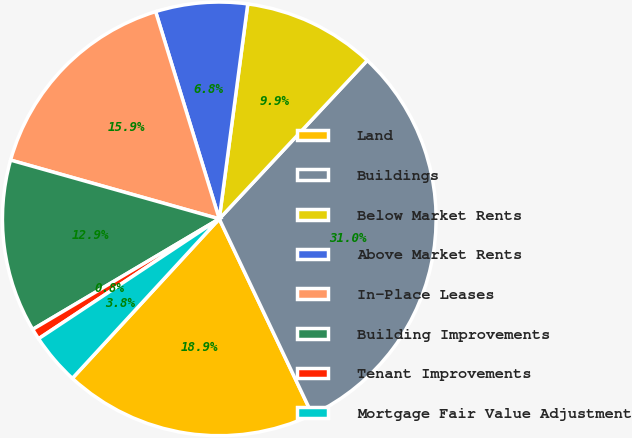Convert chart. <chart><loc_0><loc_0><loc_500><loc_500><pie_chart><fcel>Land<fcel>Buildings<fcel>Below Market Rents<fcel>Above Market Rents<fcel>In-Place Leases<fcel>Building Improvements<fcel>Tenant Improvements<fcel>Mortgage Fair Value Adjustment<nl><fcel>18.91%<fcel>30.98%<fcel>9.86%<fcel>6.84%<fcel>15.89%<fcel>12.88%<fcel>0.81%<fcel>3.83%<nl></chart> 